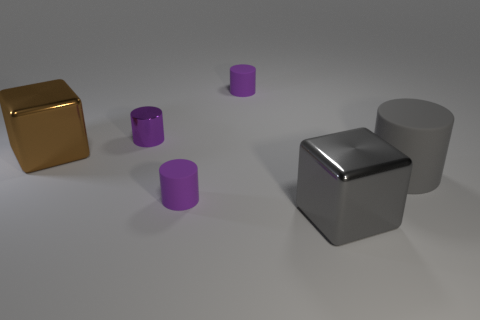What number of other brown metallic things have the same shape as the brown metal thing?
Offer a terse response. 0. Is the number of cylinders behind the gray matte object greater than the number of large green shiny spheres?
Offer a very short reply. Yes. What shape is the shiny thing that is in front of the tiny metallic thing and left of the big gray metal object?
Offer a terse response. Cube. Does the gray matte cylinder have the same size as the shiny cylinder?
Keep it short and to the point. No. There is a small purple metallic cylinder; what number of tiny purple things are right of it?
Ensure brevity in your answer.  2. Are there an equal number of tiny purple cylinders behind the small purple metal cylinder and big gray matte objects that are in front of the large cylinder?
Provide a succinct answer. No. Is the shape of the large metallic thing that is on the right side of the brown object the same as  the big brown thing?
Keep it short and to the point. Yes. There is a brown thing; is it the same size as the cylinder that is on the right side of the large gray metallic object?
Make the answer very short. Yes. How many other objects are the same color as the large rubber cylinder?
Offer a terse response. 1. Are there any brown metallic things left of the gray cylinder?
Offer a very short reply. Yes. 